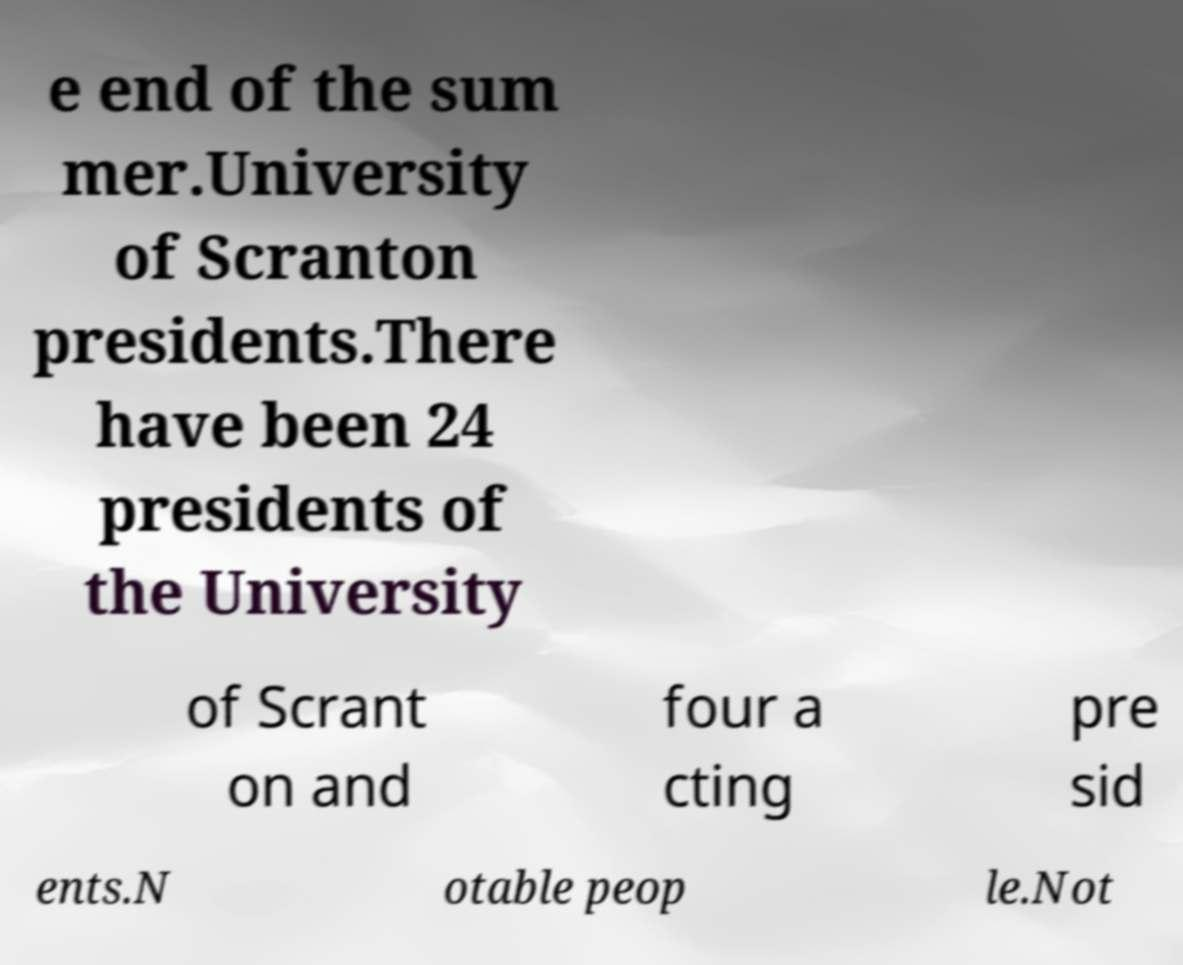Could you extract and type out the text from this image? e end of the sum mer.University of Scranton presidents.There have been 24 presidents of the University of Scrant on and four a cting pre sid ents.N otable peop le.Not 